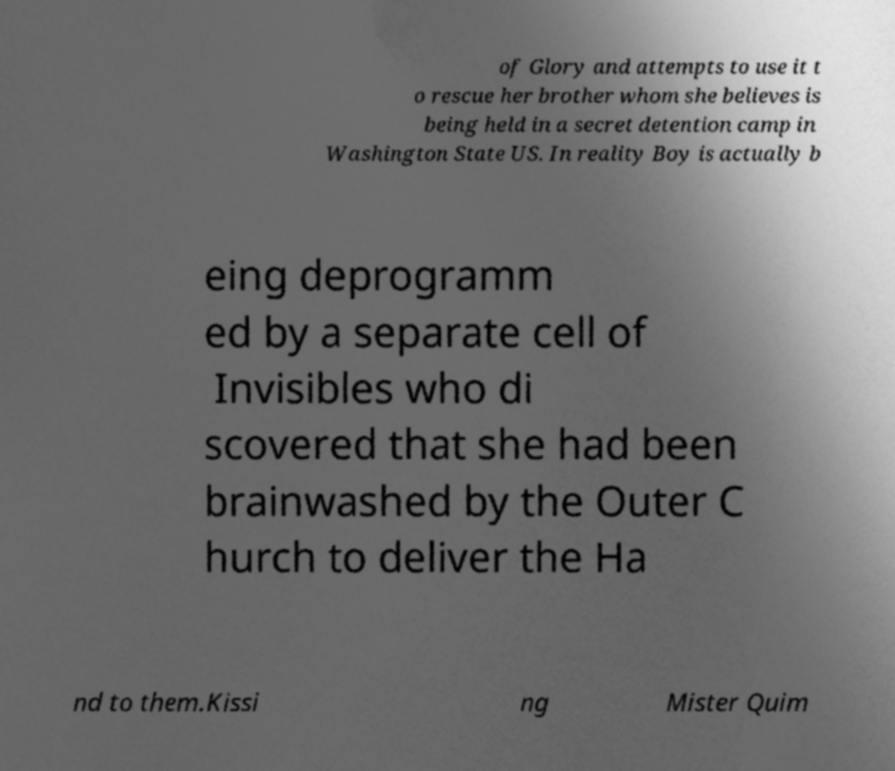What messages or text are displayed in this image? I need them in a readable, typed format. of Glory and attempts to use it t o rescue her brother whom she believes is being held in a secret detention camp in Washington State US. In reality Boy is actually b eing deprogramm ed by a separate cell of Invisibles who di scovered that she had been brainwashed by the Outer C hurch to deliver the Ha nd to them.Kissi ng Mister Quim 